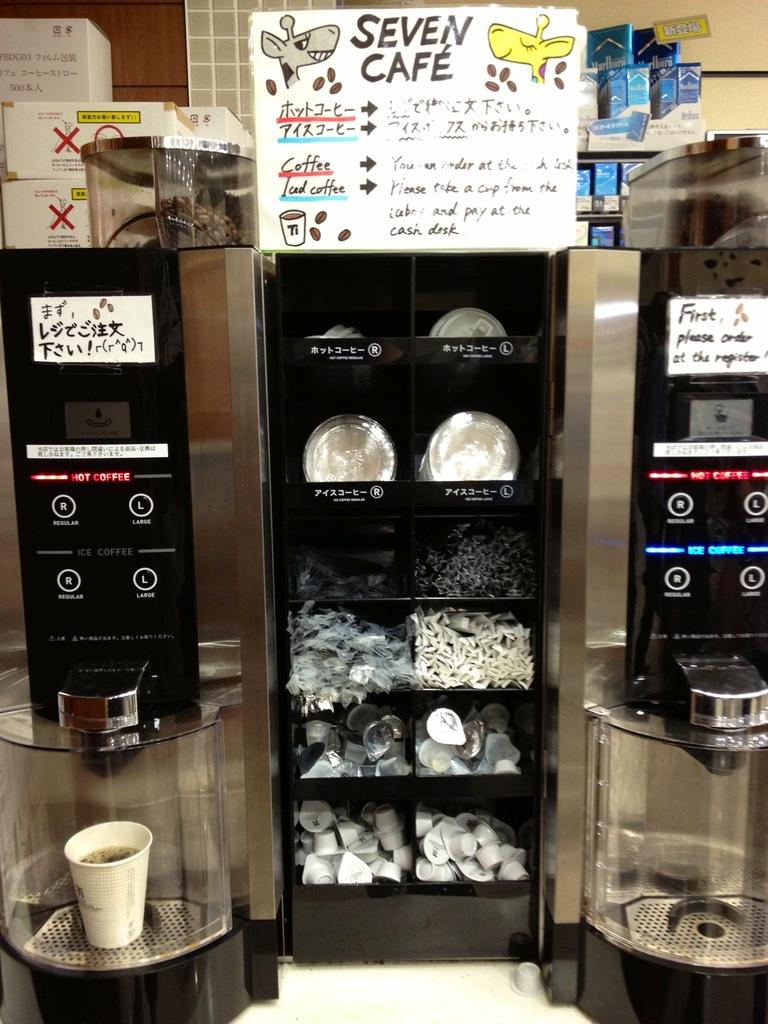Provide a one-sentence caption for the provided image. Coffee Makers and supplies in the Seven Cafe. 